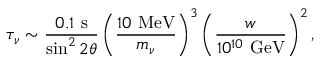<formula> <loc_0><loc_0><loc_500><loc_500>\tau _ { \nu } \sim \frac { 0 . 1 s } { \sin ^ { 2 } 2 \theta } \left ( \frac { 1 0 M e V } { m _ { \nu } } \right ) ^ { 3 } \left ( \frac { w } { 1 0 ^ { 1 0 } G e V } \right ) ^ { 2 } ,</formula> 